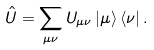<formula> <loc_0><loc_0><loc_500><loc_500>\hat { U } = \sum _ { \mu \nu } U _ { \mu \nu } \left | \mu \right > \left < \nu \right | .</formula> 